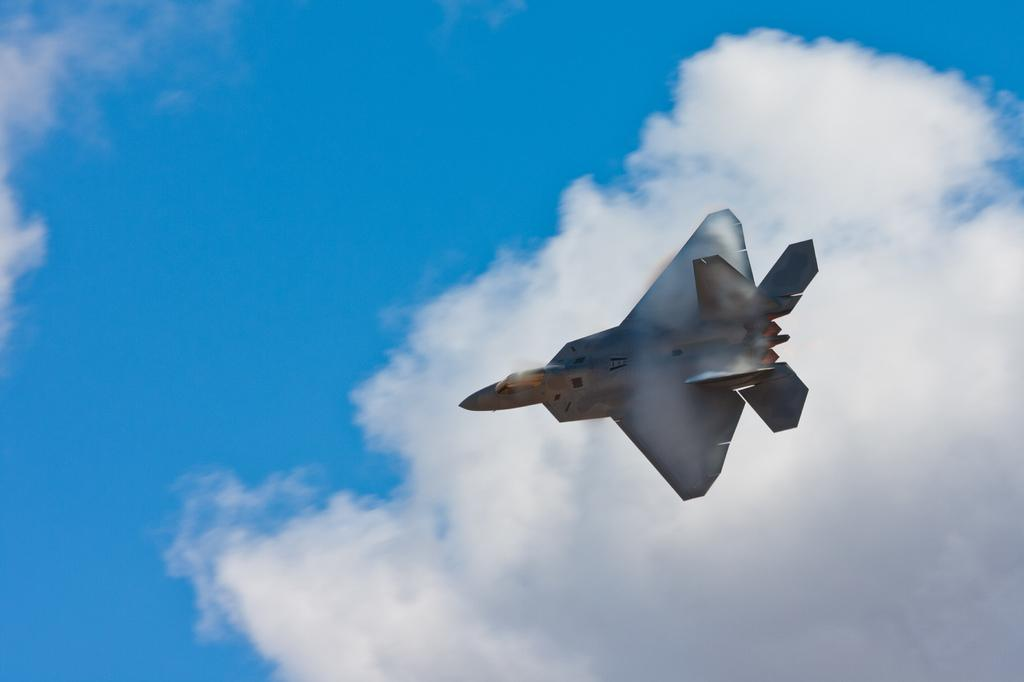What is the main subject of the image? The main subject of the image is an aircraft. What is the aircraft doing in the image? The aircraft is flying in the sky. What can be seen in the background of the image? There are clouds visible at the top of the image. What type of vest is the aircraft wearing in the image? There is no vest present in the image, as aircraft do not wear clothing. 